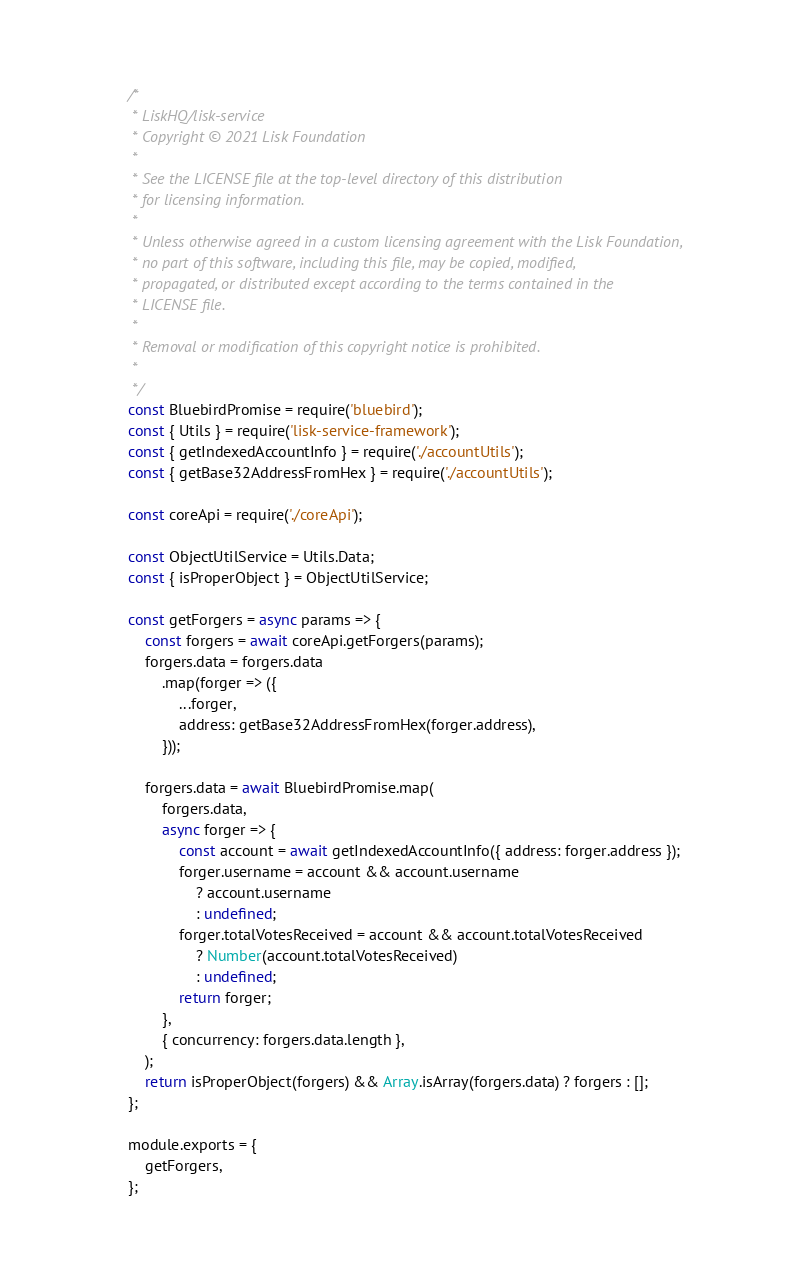<code> <loc_0><loc_0><loc_500><loc_500><_JavaScript_>/*
 * LiskHQ/lisk-service
 * Copyright © 2021 Lisk Foundation
 *
 * See the LICENSE file at the top-level directory of this distribution
 * for licensing information.
 *
 * Unless otherwise agreed in a custom licensing agreement with the Lisk Foundation,
 * no part of this software, including this file, may be copied, modified,
 * propagated, or distributed except according to the terms contained in the
 * LICENSE file.
 *
 * Removal or modification of this copyright notice is prohibited.
 *
 */
const BluebirdPromise = require('bluebird');
const { Utils } = require('lisk-service-framework');
const { getIndexedAccountInfo } = require('./accountUtils');
const { getBase32AddressFromHex } = require('./accountUtils');

const coreApi = require('./coreApi');

const ObjectUtilService = Utils.Data;
const { isProperObject } = ObjectUtilService;

const getForgers = async params => {
	const forgers = await coreApi.getForgers(params);
	forgers.data = forgers.data
		.map(forger => ({
			...forger,
			address: getBase32AddressFromHex(forger.address),
		}));

	forgers.data = await BluebirdPromise.map(
		forgers.data,
		async forger => {
			const account = await getIndexedAccountInfo({ address: forger.address });
			forger.username = account && account.username
				? account.username
				: undefined;
			forger.totalVotesReceived = account && account.totalVotesReceived
				? Number(account.totalVotesReceived)
				: undefined;
			return forger;
		},
		{ concurrency: forgers.data.length },
	);
	return isProperObject(forgers) && Array.isArray(forgers.data) ? forgers : [];
};

module.exports = {
	getForgers,
};
</code> 